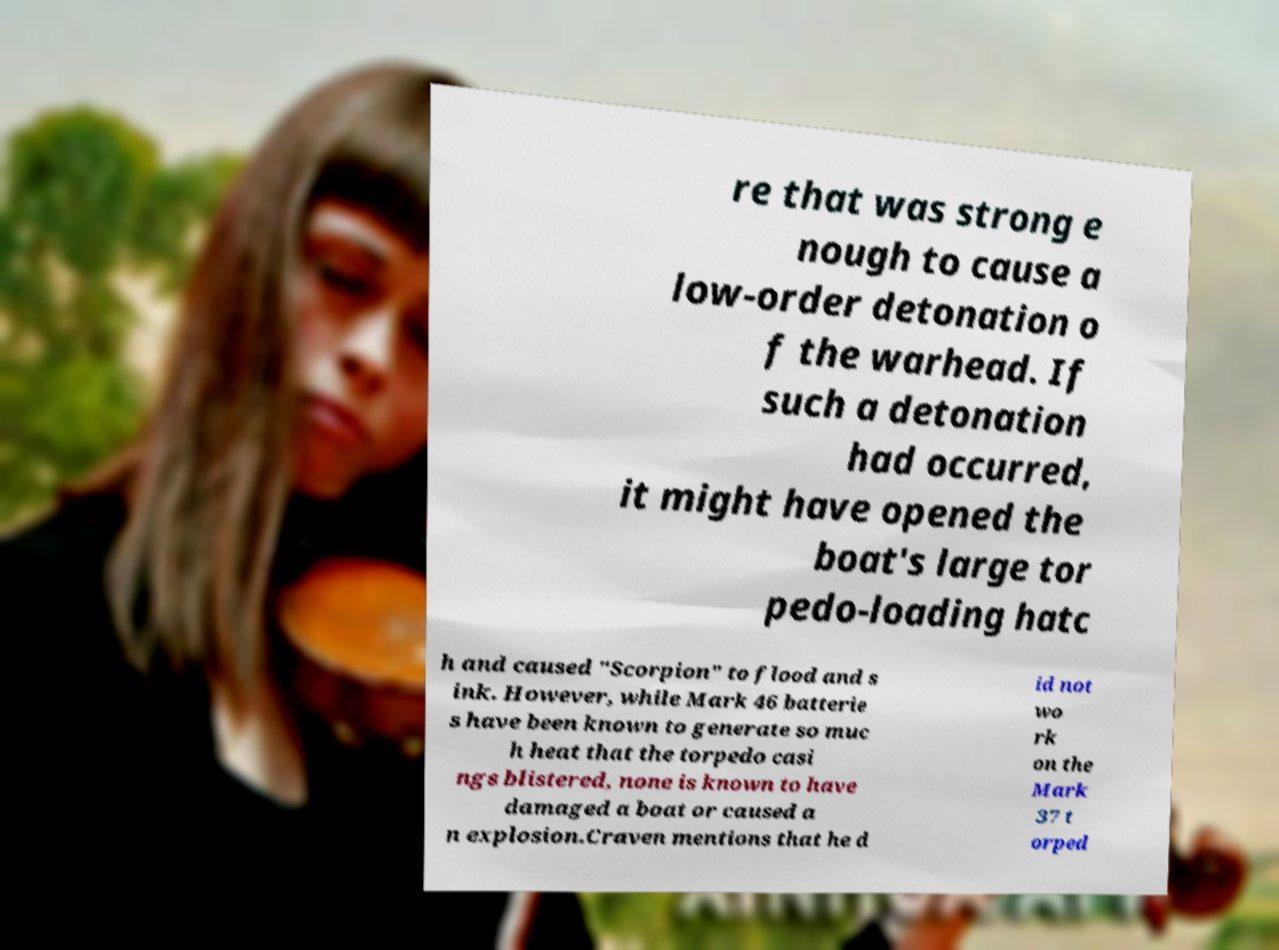Please identify and transcribe the text found in this image. re that was strong e nough to cause a low-order detonation o f the warhead. If such a detonation had occurred, it might have opened the boat's large tor pedo-loading hatc h and caused "Scorpion" to flood and s ink. However, while Mark 46 batterie s have been known to generate so muc h heat that the torpedo casi ngs blistered, none is known to have damaged a boat or caused a n explosion.Craven mentions that he d id not wo rk on the Mark 37 t orped 